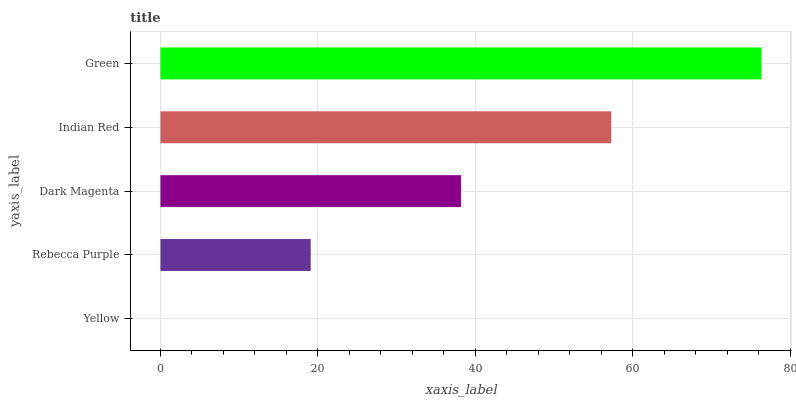Is Yellow the minimum?
Answer yes or no. Yes. Is Green the maximum?
Answer yes or no. Yes. Is Rebecca Purple the minimum?
Answer yes or no. No. Is Rebecca Purple the maximum?
Answer yes or no. No. Is Rebecca Purple greater than Yellow?
Answer yes or no. Yes. Is Yellow less than Rebecca Purple?
Answer yes or no. Yes. Is Yellow greater than Rebecca Purple?
Answer yes or no. No. Is Rebecca Purple less than Yellow?
Answer yes or no. No. Is Dark Magenta the high median?
Answer yes or no. Yes. Is Dark Magenta the low median?
Answer yes or no. Yes. Is Indian Red the high median?
Answer yes or no. No. Is Green the low median?
Answer yes or no. No. 